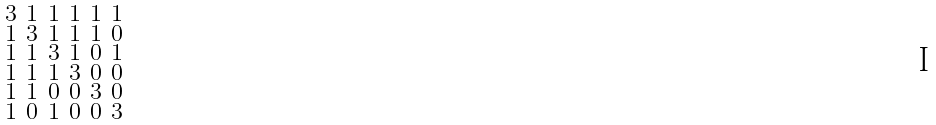<formula> <loc_0><loc_0><loc_500><loc_500>\begin{smallmatrix} 3 & 1 & 1 & 1 & 1 & 1 \\ 1 & 3 & 1 & 1 & 1 & 0 \\ 1 & 1 & 3 & 1 & 0 & 1 \\ 1 & 1 & 1 & 3 & 0 & 0 \\ 1 & 1 & 0 & 0 & 3 & 0 \\ 1 & 0 & 1 & 0 & 0 & 3 \end{smallmatrix}</formula> 